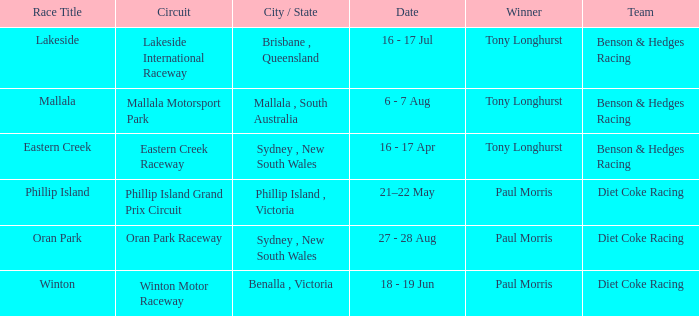What was the name of the driver that won the Lakeside race? Tony Longhurst. 